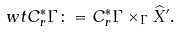<formula> <loc_0><loc_0><loc_500><loc_500>\ w t { C ^ { * } _ { r } } \Gamma \colon = C ^ { * } _ { r } \Gamma \times _ { \Gamma } \widehat { X } ^ { \prime } .</formula> 